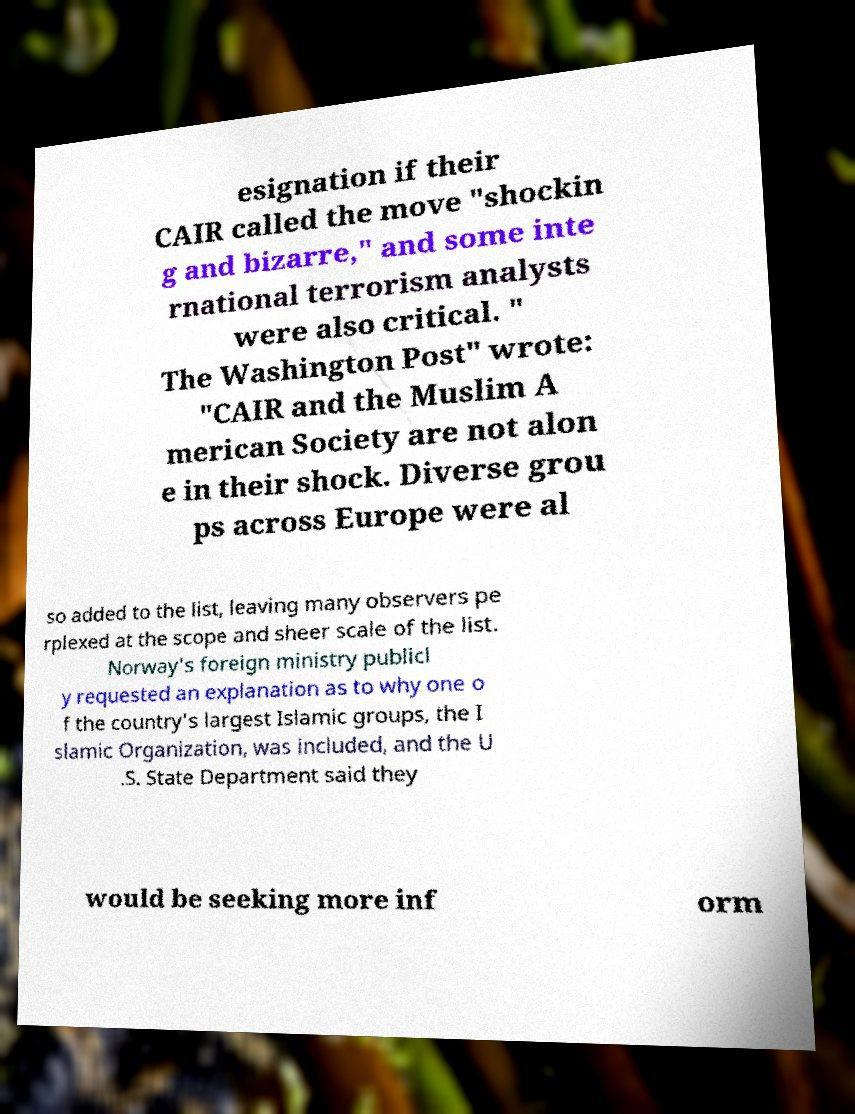Could you extract and type out the text from this image? esignation if their CAIR called the move "shockin g and bizarre," and some inte rnational terrorism analysts were also critical. " The Washington Post" wrote: "CAIR and the Muslim A merican Society are not alon e in their shock. Diverse grou ps across Europe were al so added to the list, leaving many observers pe rplexed at the scope and sheer scale of the list. Norway's foreign ministry publicl y requested an explanation as to why one o f the country's largest Islamic groups, the I slamic Organization, was included, and the U .S. State Department said they would be seeking more inf orm 